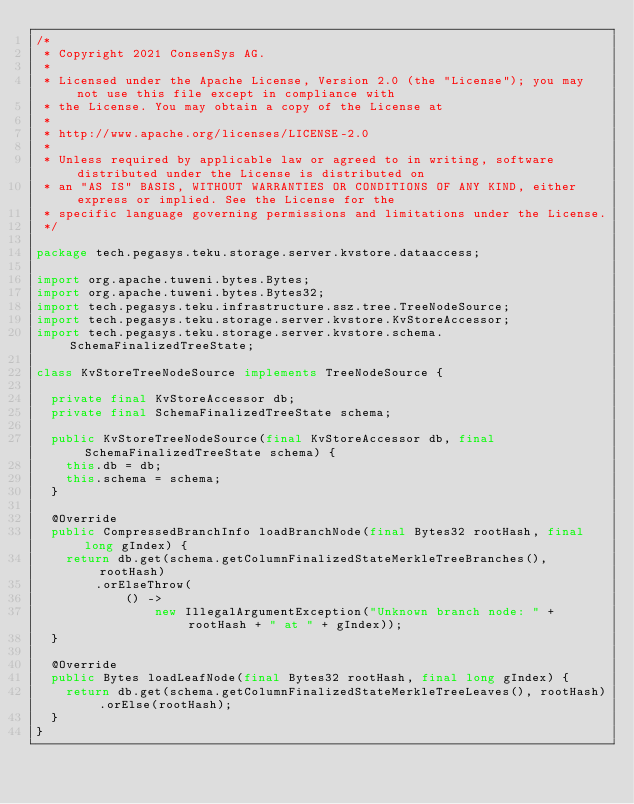<code> <loc_0><loc_0><loc_500><loc_500><_Java_>/*
 * Copyright 2021 ConsenSys AG.
 *
 * Licensed under the Apache License, Version 2.0 (the "License"); you may not use this file except in compliance with
 * the License. You may obtain a copy of the License at
 *
 * http://www.apache.org/licenses/LICENSE-2.0
 *
 * Unless required by applicable law or agreed to in writing, software distributed under the License is distributed on
 * an "AS IS" BASIS, WITHOUT WARRANTIES OR CONDITIONS OF ANY KIND, either express or implied. See the License for the
 * specific language governing permissions and limitations under the License.
 */

package tech.pegasys.teku.storage.server.kvstore.dataaccess;

import org.apache.tuweni.bytes.Bytes;
import org.apache.tuweni.bytes.Bytes32;
import tech.pegasys.teku.infrastructure.ssz.tree.TreeNodeSource;
import tech.pegasys.teku.storage.server.kvstore.KvStoreAccessor;
import tech.pegasys.teku.storage.server.kvstore.schema.SchemaFinalizedTreeState;

class KvStoreTreeNodeSource implements TreeNodeSource {

  private final KvStoreAccessor db;
  private final SchemaFinalizedTreeState schema;

  public KvStoreTreeNodeSource(final KvStoreAccessor db, final SchemaFinalizedTreeState schema) {
    this.db = db;
    this.schema = schema;
  }

  @Override
  public CompressedBranchInfo loadBranchNode(final Bytes32 rootHash, final long gIndex) {
    return db.get(schema.getColumnFinalizedStateMerkleTreeBranches(), rootHash)
        .orElseThrow(
            () ->
                new IllegalArgumentException("Unknown branch node: " + rootHash + " at " + gIndex));
  }

  @Override
  public Bytes loadLeafNode(final Bytes32 rootHash, final long gIndex) {
    return db.get(schema.getColumnFinalizedStateMerkleTreeLeaves(), rootHash).orElse(rootHash);
  }
}
</code> 